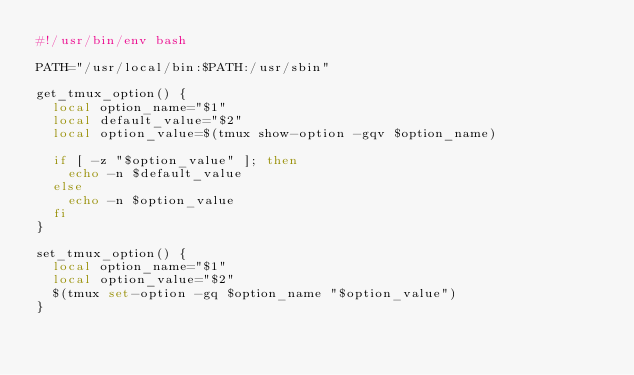Convert code to text. <code><loc_0><loc_0><loc_500><loc_500><_Bash_>#!/usr/bin/env bash

PATH="/usr/local/bin:$PATH:/usr/sbin"

get_tmux_option() {
  local option_name="$1"
  local default_value="$2"
  local option_value=$(tmux show-option -gqv $option_name)

  if [ -z "$option_value" ]; then
    echo -n $default_value
  else
    echo -n $option_value
  fi
}

set_tmux_option() {
  local option_name="$1"
  local option_value="$2"
  $(tmux set-option -gq $option_name "$option_value")
}
</code> 